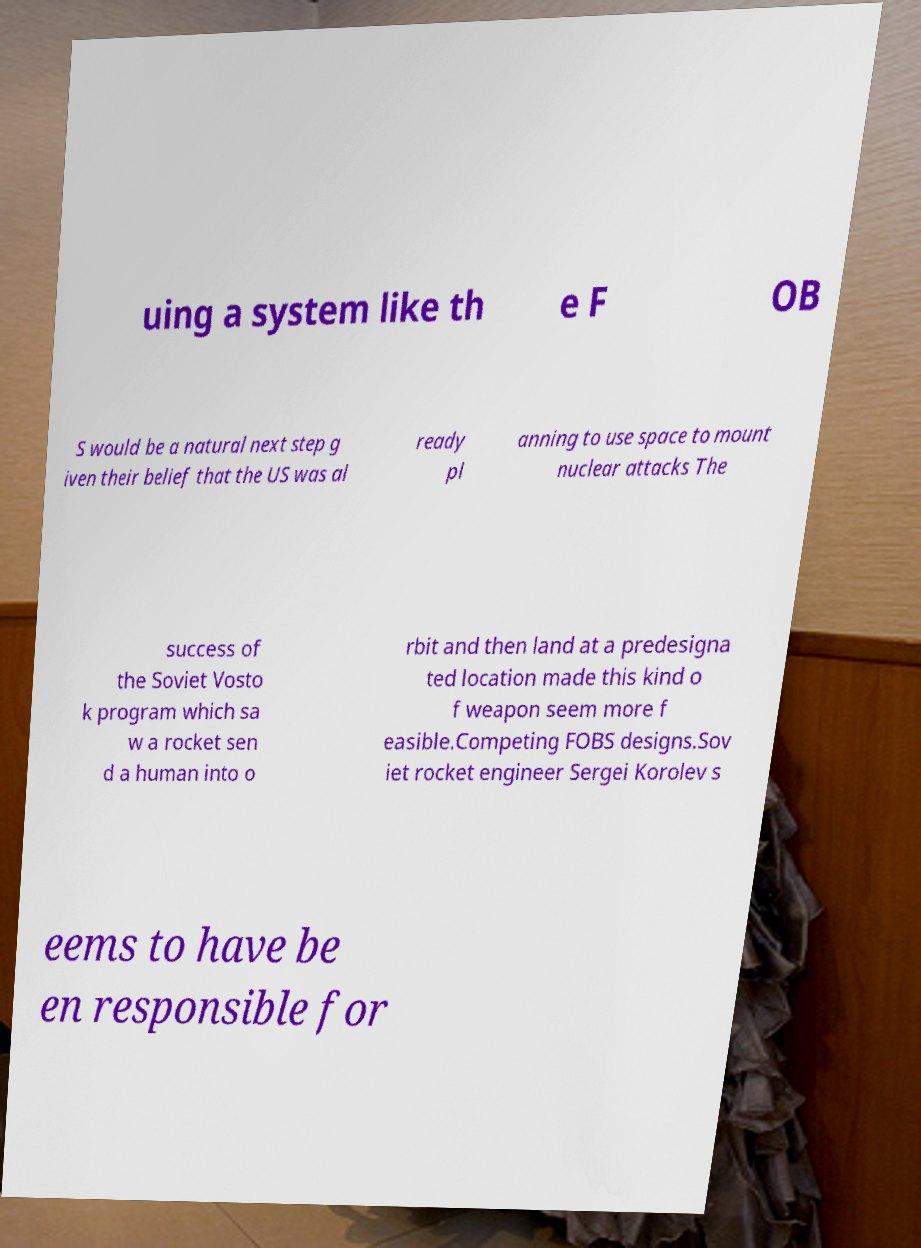Please identify and transcribe the text found in this image. uing a system like th e F OB S would be a natural next step g iven their belief that the US was al ready pl anning to use space to mount nuclear attacks The success of the Soviet Vosto k program which sa w a rocket sen d a human into o rbit and then land at a predesigna ted location made this kind o f weapon seem more f easible.Competing FOBS designs.Sov iet rocket engineer Sergei Korolev s eems to have be en responsible for 